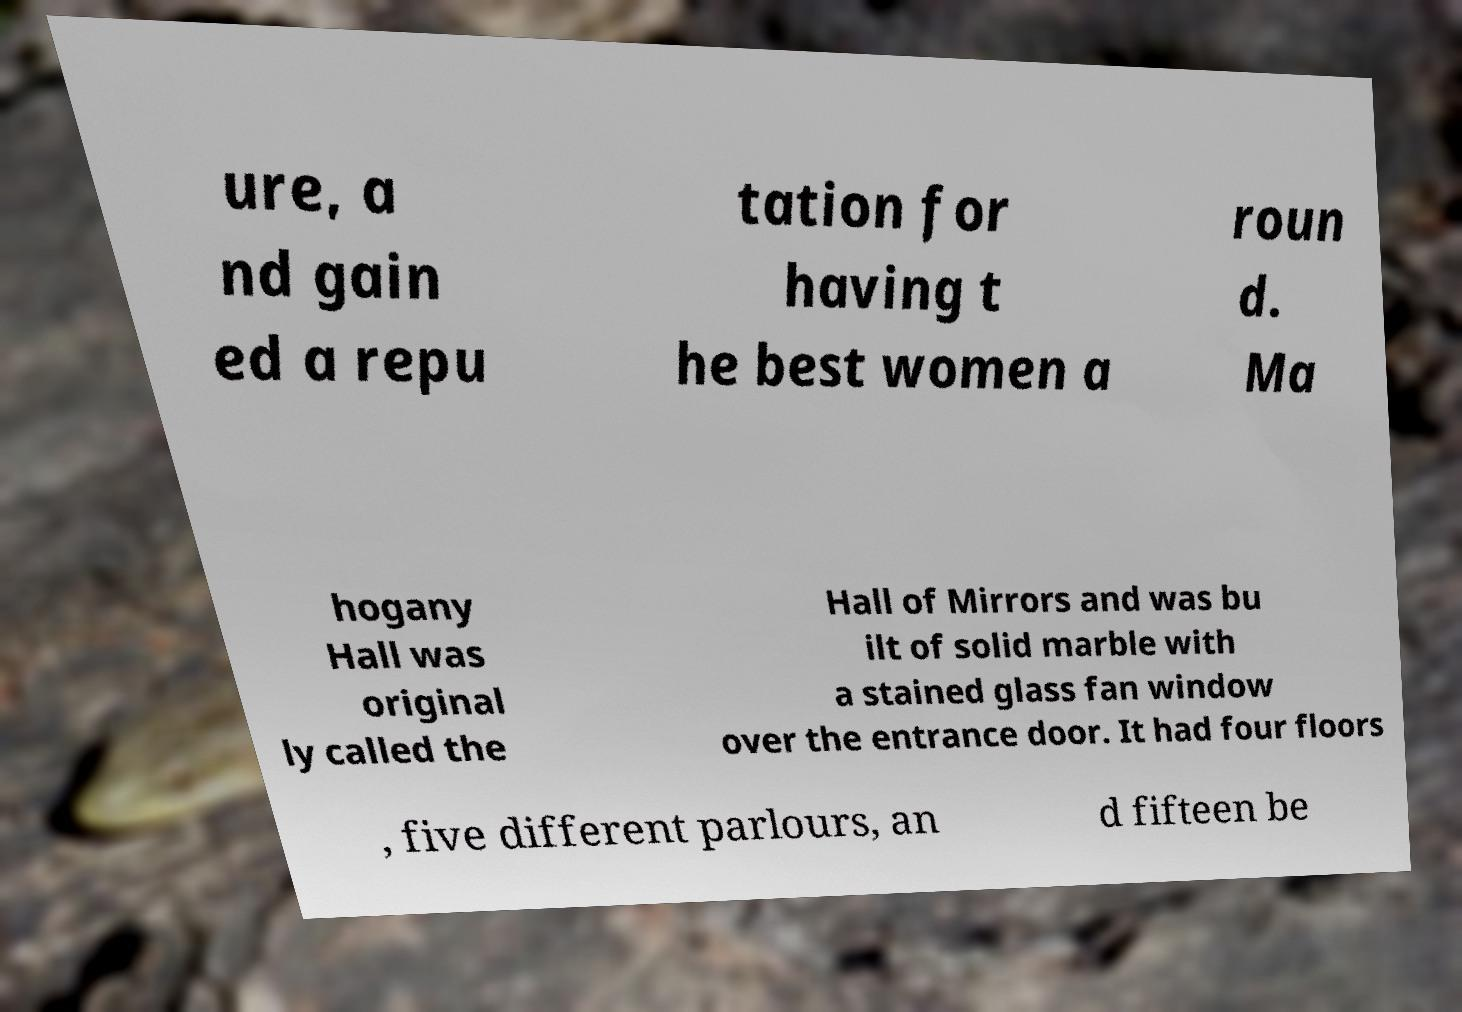I need the written content from this picture converted into text. Can you do that? ure, a nd gain ed a repu tation for having t he best women a roun d. Ma hogany Hall was original ly called the Hall of Mirrors and was bu ilt of solid marble with a stained glass fan window over the entrance door. It had four floors , five different parlours, an d fifteen be 